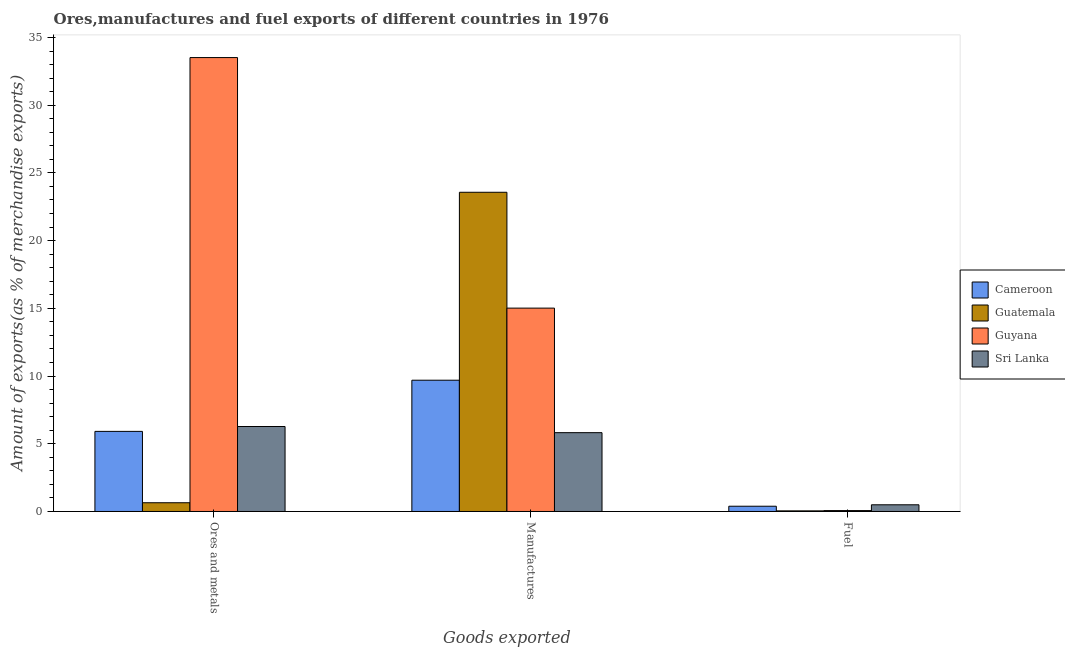How many groups of bars are there?
Keep it short and to the point. 3. Are the number of bars per tick equal to the number of legend labels?
Ensure brevity in your answer.  Yes. Are the number of bars on each tick of the X-axis equal?
Ensure brevity in your answer.  Yes. How many bars are there on the 2nd tick from the left?
Ensure brevity in your answer.  4. How many bars are there on the 3rd tick from the right?
Offer a terse response. 4. What is the label of the 3rd group of bars from the left?
Your answer should be very brief. Fuel. What is the percentage of fuel exports in Guatemala?
Your response must be concise. 0.05. Across all countries, what is the maximum percentage of ores and metals exports?
Your answer should be very brief. 33.52. Across all countries, what is the minimum percentage of ores and metals exports?
Provide a short and direct response. 0.65. In which country was the percentage of ores and metals exports maximum?
Your answer should be very brief. Guyana. In which country was the percentage of fuel exports minimum?
Offer a terse response. Guatemala. What is the total percentage of manufactures exports in the graph?
Offer a very short reply. 54.1. What is the difference between the percentage of manufactures exports in Guyana and that in Guatemala?
Your answer should be very brief. -8.55. What is the difference between the percentage of manufactures exports in Cameroon and the percentage of fuel exports in Sri Lanka?
Offer a terse response. 9.2. What is the average percentage of ores and metals exports per country?
Offer a very short reply. 11.59. What is the difference between the percentage of fuel exports and percentage of ores and metals exports in Sri Lanka?
Your answer should be compact. -5.78. What is the ratio of the percentage of fuel exports in Guatemala to that in Sri Lanka?
Your answer should be compact. 0.09. What is the difference between the highest and the second highest percentage of ores and metals exports?
Provide a short and direct response. 27.24. What is the difference between the highest and the lowest percentage of fuel exports?
Your answer should be compact. 0.45. In how many countries, is the percentage of manufactures exports greater than the average percentage of manufactures exports taken over all countries?
Offer a terse response. 2. Is the sum of the percentage of fuel exports in Guatemala and Cameroon greater than the maximum percentage of ores and metals exports across all countries?
Make the answer very short. No. What does the 2nd bar from the left in Manufactures represents?
Offer a very short reply. Guatemala. What does the 4th bar from the right in Manufactures represents?
Provide a succinct answer. Cameroon. Is it the case that in every country, the sum of the percentage of ores and metals exports and percentage of manufactures exports is greater than the percentage of fuel exports?
Provide a short and direct response. Yes. How many bars are there?
Keep it short and to the point. 12. Are all the bars in the graph horizontal?
Your response must be concise. No. What is the difference between two consecutive major ticks on the Y-axis?
Provide a succinct answer. 5. Does the graph contain grids?
Provide a short and direct response. No. Where does the legend appear in the graph?
Offer a very short reply. Center right. What is the title of the graph?
Your response must be concise. Ores,manufactures and fuel exports of different countries in 1976. What is the label or title of the X-axis?
Offer a very short reply. Goods exported. What is the label or title of the Y-axis?
Your answer should be very brief. Amount of exports(as % of merchandise exports). What is the Amount of exports(as % of merchandise exports) in Cameroon in Ores and metals?
Give a very brief answer. 5.91. What is the Amount of exports(as % of merchandise exports) in Guatemala in Ores and metals?
Provide a short and direct response. 0.65. What is the Amount of exports(as % of merchandise exports) of Guyana in Ores and metals?
Your answer should be compact. 33.52. What is the Amount of exports(as % of merchandise exports) in Sri Lanka in Ores and metals?
Offer a terse response. 6.27. What is the Amount of exports(as % of merchandise exports) in Cameroon in Manufactures?
Keep it short and to the point. 9.69. What is the Amount of exports(as % of merchandise exports) in Guatemala in Manufactures?
Keep it short and to the point. 23.57. What is the Amount of exports(as % of merchandise exports) in Guyana in Manufactures?
Your answer should be compact. 15.02. What is the Amount of exports(as % of merchandise exports) in Sri Lanka in Manufactures?
Provide a short and direct response. 5.82. What is the Amount of exports(as % of merchandise exports) of Cameroon in Fuel?
Offer a terse response. 0.39. What is the Amount of exports(as % of merchandise exports) of Guatemala in Fuel?
Your response must be concise. 0.05. What is the Amount of exports(as % of merchandise exports) of Guyana in Fuel?
Keep it short and to the point. 0.07. What is the Amount of exports(as % of merchandise exports) of Sri Lanka in Fuel?
Provide a short and direct response. 0.49. Across all Goods exported, what is the maximum Amount of exports(as % of merchandise exports) in Cameroon?
Ensure brevity in your answer.  9.69. Across all Goods exported, what is the maximum Amount of exports(as % of merchandise exports) of Guatemala?
Provide a succinct answer. 23.57. Across all Goods exported, what is the maximum Amount of exports(as % of merchandise exports) of Guyana?
Make the answer very short. 33.52. Across all Goods exported, what is the maximum Amount of exports(as % of merchandise exports) of Sri Lanka?
Your answer should be very brief. 6.27. Across all Goods exported, what is the minimum Amount of exports(as % of merchandise exports) in Cameroon?
Offer a terse response. 0.39. Across all Goods exported, what is the minimum Amount of exports(as % of merchandise exports) in Guatemala?
Keep it short and to the point. 0.05. Across all Goods exported, what is the minimum Amount of exports(as % of merchandise exports) of Guyana?
Ensure brevity in your answer.  0.07. Across all Goods exported, what is the minimum Amount of exports(as % of merchandise exports) of Sri Lanka?
Keep it short and to the point. 0.49. What is the total Amount of exports(as % of merchandise exports) of Cameroon in the graph?
Provide a short and direct response. 16. What is the total Amount of exports(as % of merchandise exports) in Guatemala in the graph?
Offer a very short reply. 24.26. What is the total Amount of exports(as % of merchandise exports) in Guyana in the graph?
Your answer should be very brief. 48.6. What is the total Amount of exports(as % of merchandise exports) of Sri Lanka in the graph?
Your answer should be compact. 12.59. What is the difference between the Amount of exports(as % of merchandise exports) of Cameroon in Ores and metals and that in Manufactures?
Ensure brevity in your answer.  -3.78. What is the difference between the Amount of exports(as % of merchandise exports) in Guatemala in Ores and metals and that in Manufactures?
Provide a short and direct response. -22.92. What is the difference between the Amount of exports(as % of merchandise exports) of Guyana in Ores and metals and that in Manufactures?
Offer a terse response. 18.5. What is the difference between the Amount of exports(as % of merchandise exports) of Sri Lanka in Ores and metals and that in Manufactures?
Provide a short and direct response. 0.45. What is the difference between the Amount of exports(as % of merchandise exports) in Cameroon in Ores and metals and that in Fuel?
Provide a succinct answer. 5.53. What is the difference between the Amount of exports(as % of merchandise exports) of Guatemala in Ores and metals and that in Fuel?
Provide a succinct answer. 0.6. What is the difference between the Amount of exports(as % of merchandise exports) in Guyana in Ores and metals and that in Fuel?
Offer a terse response. 33.45. What is the difference between the Amount of exports(as % of merchandise exports) in Sri Lanka in Ores and metals and that in Fuel?
Give a very brief answer. 5.78. What is the difference between the Amount of exports(as % of merchandise exports) of Cameroon in Manufactures and that in Fuel?
Make the answer very short. 9.3. What is the difference between the Amount of exports(as % of merchandise exports) in Guatemala in Manufactures and that in Fuel?
Offer a terse response. 23.52. What is the difference between the Amount of exports(as % of merchandise exports) of Guyana in Manufactures and that in Fuel?
Your response must be concise. 14.95. What is the difference between the Amount of exports(as % of merchandise exports) in Sri Lanka in Manufactures and that in Fuel?
Give a very brief answer. 5.33. What is the difference between the Amount of exports(as % of merchandise exports) of Cameroon in Ores and metals and the Amount of exports(as % of merchandise exports) of Guatemala in Manufactures?
Make the answer very short. -17.65. What is the difference between the Amount of exports(as % of merchandise exports) of Cameroon in Ores and metals and the Amount of exports(as % of merchandise exports) of Guyana in Manufactures?
Provide a succinct answer. -9.1. What is the difference between the Amount of exports(as % of merchandise exports) of Cameroon in Ores and metals and the Amount of exports(as % of merchandise exports) of Sri Lanka in Manufactures?
Keep it short and to the point. 0.09. What is the difference between the Amount of exports(as % of merchandise exports) of Guatemala in Ores and metals and the Amount of exports(as % of merchandise exports) of Guyana in Manufactures?
Your answer should be very brief. -14.37. What is the difference between the Amount of exports(as % of merchandise exports) in Guatemala in Ores and metals and the Amount of exports(as % of merchandise exports) in Sri Lanka in Manufactures?
Your answer should be compact. -5.18. What is the difference between the Amount of exports(as % of merchandise exports) in Guyana in Ores and metals and the Amount of exports(as % of merchandise exports) in Sri Lanka in Manufactures?
Provide a succinct answer. 27.7. What is the difference between the Amount of exports(as % of merchandise exports) of Cameroon in Ores and metals and the Amount of exports(as % of merchandise exports) of Guatemala in Fuel?
Keep it short and to the point. 5.87. What is the difference between the Amount of exports(as % of merchandise exports) of Cameroon in Ores and metals and the Amount of exports(as % of merchandise exports) of Guyana in Fuel?
Offer a terse response. 5.85. What is the difference between the Amount of exports(as % of merchandise exports) of Cameroon in Ores and metals and the Amount of exports(as % of merchandise exports) of Sri Lanka in Fuel?
Your answer should be compact. 5.42. What is the difference between the Amount of exports(as % of merchandise exports) in Guatemala in Ores and metals and the Amount of exports(as % of merchandise exports) in Guyana in Fuel?
Make the answer very short. 0.58. What is the difference between the Amount of exports(as % of merchandise exports) of Guatemala in Ores and metals and the Amount of exports(as % of merchandise exports) of Sri Lanka in Fuel?
Offer a very short reply. 0.15. What is the difference between the Amount of exports(as % of merchandise exports) in Guyana in Ores and metals and the Amount of exports(as % of merchandise exports) in Sri Lanka in Fuel?
Provide a short and direct response. 33.02. What is the difference between the Amount of exports(as % of merchandise exports) in Cameroon in Manufactures and the Amount of exports(as % of merchandise exports) in Guatemala in Fuel?
Provide a succinct answer. 9.65. What is the difference between the Amount of exports(as % of merchandise exports) of Cameroon in Manufactures and the Amount of exports(as % of merchandise exports) of Guyana in Fuel?
Your answer should be compact. 9.63. What is the difference between the Amount of exports(as % of merchandise exports) in Cameroon in Manufactures and the Amount of exports(as % of merchandise exports) in Sri Lanka in Fuel?
Give a very brief answer. 9.2. What is the difference between the Amount of exports(as % of merchandise exports) in Guatemala in Manufactures and the Amount of exports(as % of merchandise exports) in Guyana in Fuel?
Make the answer very short. 23.5. What is the difference between the Amount of exports(as % of merchandise exports) in Guatemala in Manufactures and the Amount of exports(as % of merchandise exports) in Sri Lanka in Fuel?
Offer a very short reply. 23.08. What is the difference between the Amount of exports(as % of merchandise exports) of Guyana in Manufactures and the Amount of exports(as % of merchandise exports) of Sri Lanka in Fuel?
Your response must be concise. 14.52. What is the average Amount of exports(as % of merchandise exports) of Cameroon per Goods exported?
Provide a short and direct response. 5.33. What is the average Amount of exports(as % of merchandise exports) in Guatemala per Goods exported?
Your response must be concise. 8.09. What is the average Amount of exports(as % of merchandise exports) of Guyana per Goods exported?
Offer a terse response. 16.2. What is the average Amount of exports(as % of merchandise exports) in Sri Lanka per Goods exported?
Ensure brevity in your answer.  4.2. What is the difference between the Amount of exports(as % of merchandise exports) of Cameroon and Amount of exports(as % of merchandise exports) of Guatemala in Ores and metals?
Make the answer very short. 5.27. What is the difference between the Amount of exports(as % of merchandise exports) in Cameroon and Amount of exports(as % of merchandise exports) in Guyana in Ores and metals?
Your answer should be compact. -27.6. What is the difference between the Amount of exports(as % of merchandise exports) in Cameroon and Amount of exports(as % of merchandise exports) in Sri Lanka in Ores and metals?
Provide a succinct answer. -0.36. What is the difference between the Amount of exports(as % of merchandise exports) in Guatemala and Amount of exports(as % of merchandise exports) in Guyana in Ores and metals?
Keep it short and to the point. -32.87. What is the difference between the Amount of exports(as % of merchandise exports) in Guatemala and Amount of exports(as % of merchandise exports) in Sri Lanka in Ores and metals?
Your answer should be compact. -5.63. What is the difference between the Amount of exports(as % of merchandise exports) of Guyana and Amount of exports(as % of merchandise exports) of Sri Lanka in Ores and metals?
Provide a short and direct response. 27.24. What is the difference between the Amount of exports(as % of merchandise exports) in Cameroon and Amount of exports(as % of merchandise exports) in Guatemala in Manufactures?
Keep it short and to the point. -13.88. What is the difference between the Amount of exports(as % of merchandise exports) in Cameroon and Amount of exports(as % of merchandise exports) in Guyana in Manufactures?
Give a very brief answer. -5.32. What is the difference between the Amount of exports(as % of merchandise exports) in Cameroon and Amount of exports(as % of merchandise exports) in Sri Lanka in Manufactures?
Provide a succinct answer. 3.87. What is the difference between the Amount of exports(as % of merchandise exports) in Guatemala and Amount of exports(as % of merchandise exports) in Guyana in Manufactures?
Provide a short and direct response. 8.55. What is the difference between the Amount of exports(as % of merchandise exports) of Guatemala and Amount of exports(as % of merchandise exports) of Sri Lanka in Manufactures?
Offer a very short reply. 17.75. What is the difference between the Amount of exports(as % of merchandise exports) of Guyana and Amount of exports(as % of merchandise exports) of Sri Lanka in Manufactures?
Your response must be concise. 9.2. What is the difference between the Amount of exports(as % of merchandise exports) in Cameroon and Amount of exports(as % of merchandise exports) in Guatemala in Fuel?
Offer a very short reply. 0.34. What is the difference between the Amount of exports(as % of merchandise exports) in Cameroon and Amount of exports(as % of merchandise exports) in Guyana in Fuel?
Ensure brevity in your answer.  0.32. What is the difference between the Amount of exports(as % of merchandise exports) of Cameroon and Amount of exports(as % of merchandise exports) of Sri Lanka in Fuel?
Provide a short and direct response. -0.11. What is the difference between the Amount of exports(as % of merchandise exports) of Guatemala and Amount of exports(as % of merchandise exports) of Guyana in Fuel?
Offer a very short reply. -0.02. What is the difference between the Amount of exports(as % of merchandise exports) of Guatemala and Amount of exports(as % of merchandise exports) of Sri Lanka in Fuel?
Ensure brevity in your answer.  -0.45. What is the difference between the Amount of exports(as % of merchandise exports) of Guyana and Amount of exports(as % of merchandise exports) of Sri Lanka in Fuel?
Offer a terse response. -0.43. What is the ratio of the Amount of exports(as % of merchandise exports) in Cameroon in Ores and metals to that in Manufactures?
Ensure brevity in your answer.  0.61. What is the ratio of the Amount of exports(as % of merchandise exports) in Guatemala in Ores and metals to that in Manufactures?
Provide a short and direct response. 0.03. What is the ratio of the Amount of exports(as % of merchandise exports) of Guyana in Ores and metals to that in Manufactures?
Offer a very short reply. 2.23. What is the ratio of the Amount of exports(as % of merchandise exports) of Sri Lanka in Ores and metals to that in Manufactures?
Ensure brevity in your answer.  1.08. What is the ratio of the Amount of exports(as % of merchandise exports) of Cameroon in Ores and metals to that in Fuel?
Offer a very short reply. 15.24. What is the ratio of the Amount of exports(as % of merchandise exports) of Guatemala in Ores and metals to that in Fuel?
Offer a very short reply. 14.33. What is the ratio of the Amount of exports(as % of merchandise exports) in Guyana in Ores and metals to that in Fuel?
Your response must be concise. 509.38. What is the ratio of the Amount of exports(as % of merchandise exports) in Sri Lanka in Ores and metals to that in Fuel?
Give a very brief answer. 12.7. What is the ratio of the Amount of exports(as % of merchandise exports) in Cameroon in Manufactures to that in Fuel?
Keep it short and to the point. 24.97. What is the ratio of the Amount of exports(as % of merchandise exports) of Guatemala in Manufactures to that in Fuel?
Provide a short and direct response. 523.58. What is the ratio of the Amount of exports(as % of merchandise exports) in Guyana in Manufactures to that in Fuel?
Your answer should be very brief. 228.21. What is the ratio of the Amount of exports(as % of merchandise exports) of Sri Lanka in Manufactures to that in Fuel?
Offer a very short reply. 11.78. What is the difference between the highest and the second highest Amount of exports(as % of merchandise exports) in Cameroon?
Keep it short and to the point. 3.78. What is the difference between the highest and the second highest Amount of exports(as % of merchandise exports) in Guatemala?
Ensure brevity in your answer.  22.92. What is the difference between the highest and the second highest Amount of exports(as % of merchandise exports) in Guyana?
Offer a very short reply. 18.5. What is the difference between the highest and the second highest Amount of exports(as % of merchandise exports) in Sri Lanka?
Give a very brief answer. 0.45. What is the difference between the highest and the lowest Amount of exports(as % of merchandise exports) in Cameroon?
Make the answer very short. 9.3. What is the difference between the highest and the lowest Amount of exports(as % of merchandise exports) in Guatemala?
Give a very brief answer. 23.52. What is the difference between the highest and the lowest Amount of exports(as % of merchandise exports) in Guyana?
Make the answer very short. 33.45. What is the difference between the highest and the lowest Amount of exports(as % of merchandise exports) in Sri Lanka?
Your response must be concise. 5.78. 